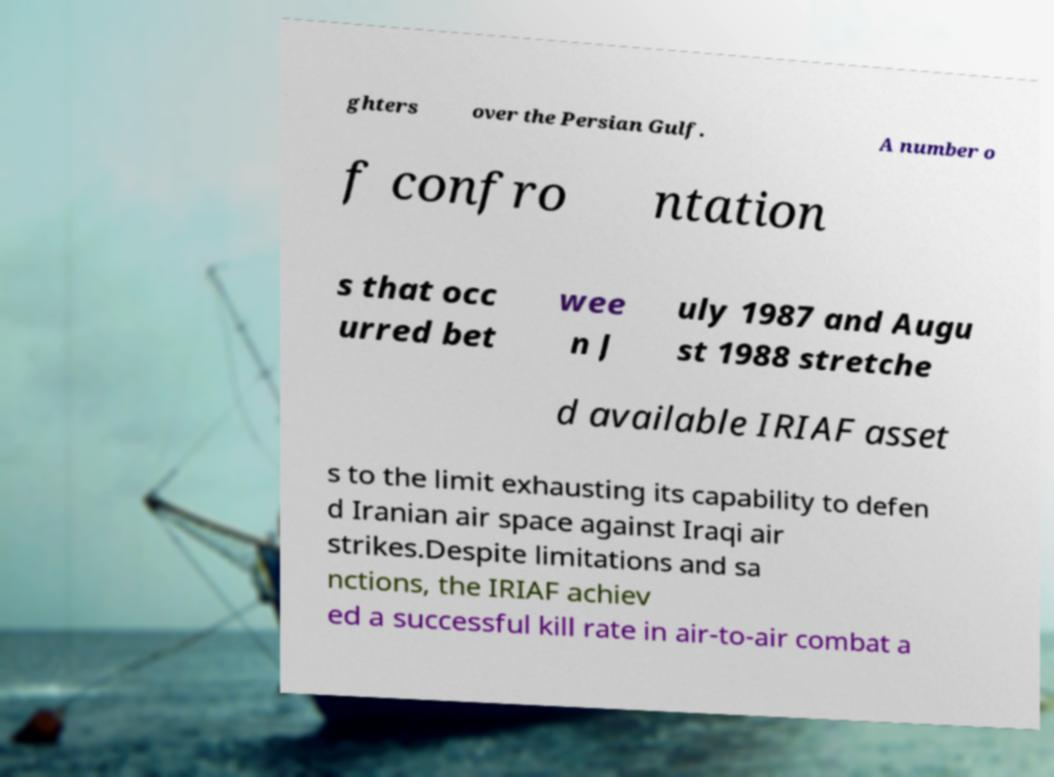Could you assist in decoding the text presented in this image and type it out clearly? ghters over the Persian Gulf. A number o f confro ntation s that occ urred bet wee n J uly 1987 and Augu st 1988 stretche d available IRIAF asset s to the limit exhausting its capability to defen d Iranian air space against Iraqi air strikes.Despite limitations and sa nctions, the IRIAF achiev ed a successful kill rate in air-to-air combat a 